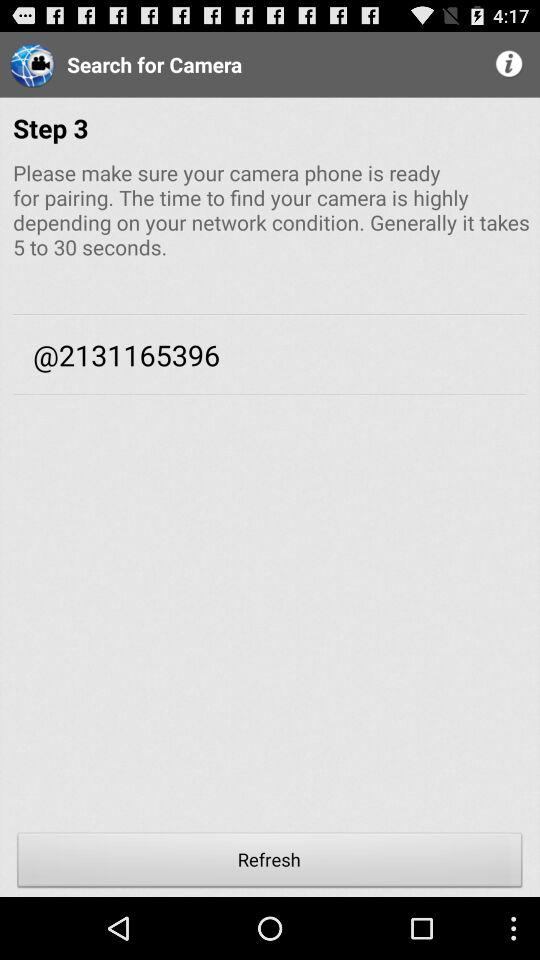How much time does it generally take? Generally it takes 5 to 30 seconds. 